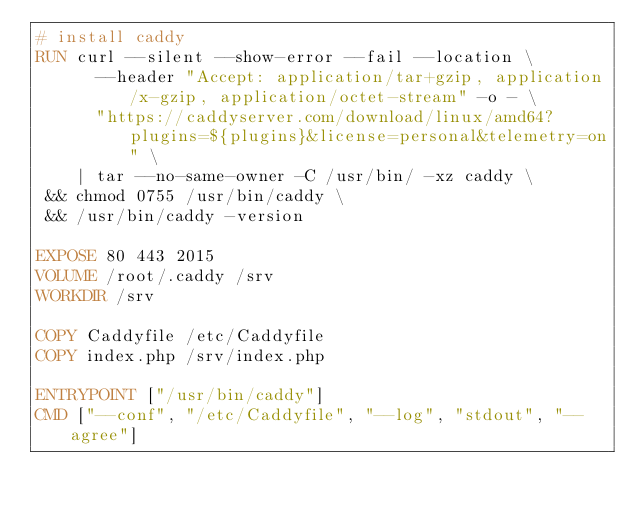<code> <loc_0><loc_0><loc_500><loc_500><_Dockerfile_># install caddy
RUN curl --silent --show-error --fail --location \
      --header "Accept: application/tar+gzip, application/x-gzip, application/octet-stream" -o - \
      "https://caddyserver.com/download/linux/amd64?plugins=${plugins}&license=personal&telemetry=on" \
    | tar --no-same-owner -C /usr/bin/ -xz caddy \
 && chmod 0755 /usr/bin/caddy \
 && /usr/bin/caddy -version

EXPOSE 80 443 2015
VOLUME /root/.caddy /srv
WORKDIR /srv

COPY Caddyfile /etc/Caddyfile
COPY index.php /srv/index.php

ENTRYPOINT ["/usr/bin/caddy"]
CMD ["--conf", "/etc/Caddyfile", "--log", "stdout", "--agree"]
</code> 